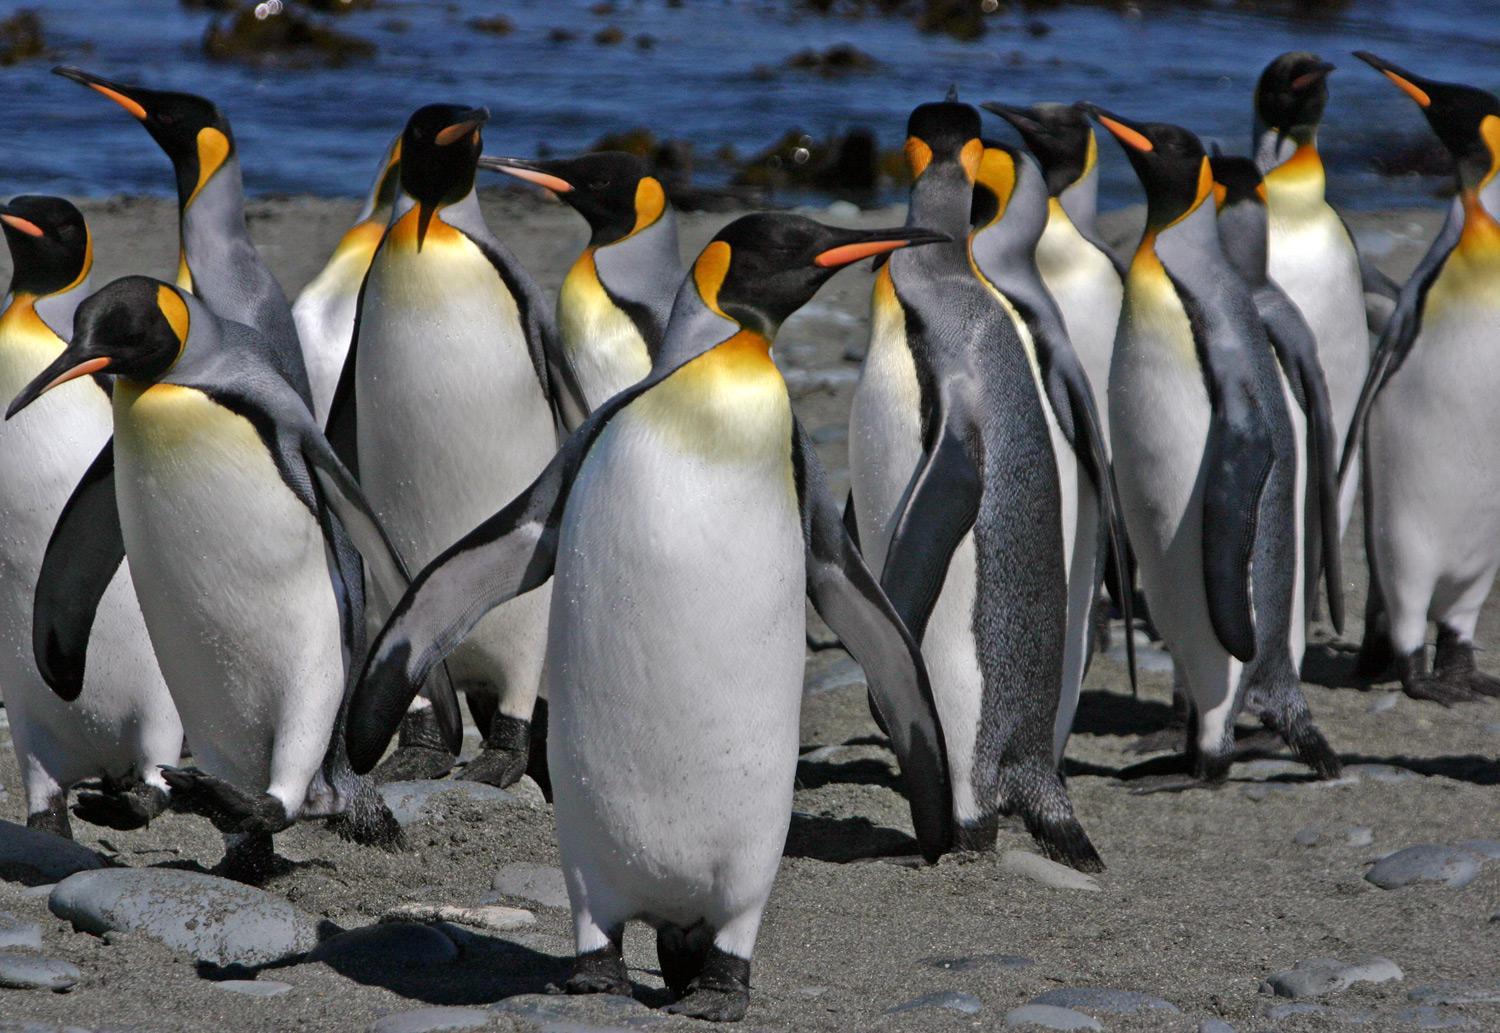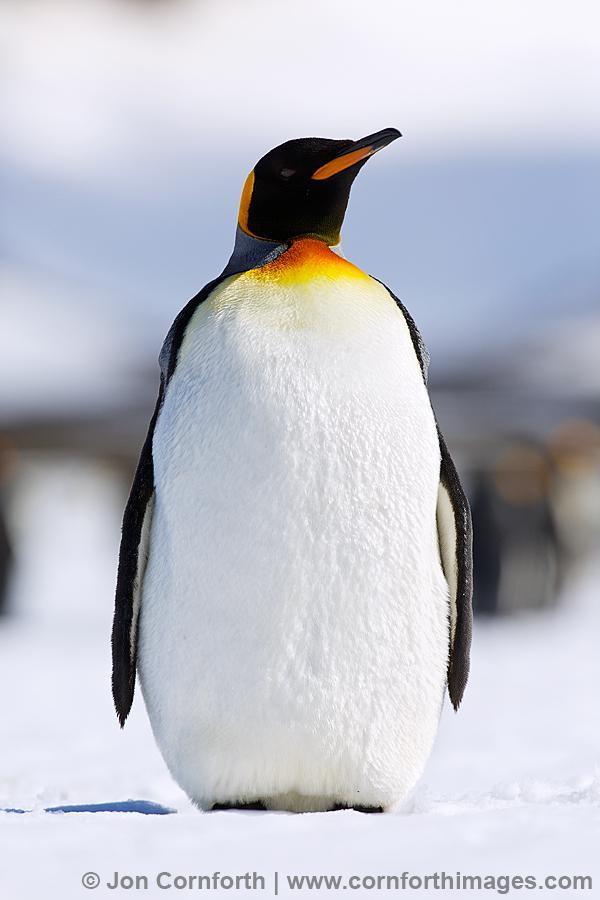The first image is the image on the left, the second image is the image on the right. Considering the images on both sides, is "There are no more than 4 penguins." valid? Answer yes or no. No. The first image is the image on the left, the second image is the image on the right. Given the left and right images, does the statement "At least one image contains only two penguins facing each other." hold true? Answer yes or no. No. 